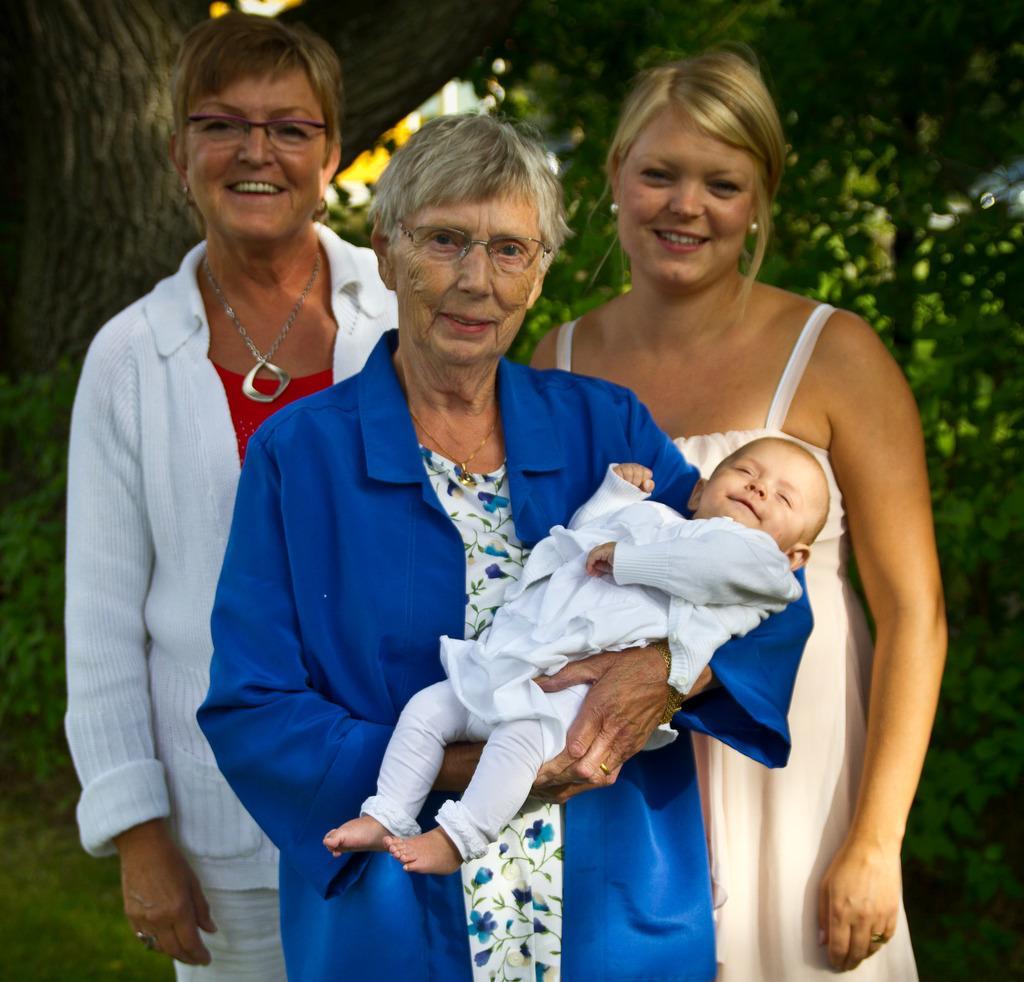In one or two sentences, can you explain what this image depicts? In this image I can see four people with different color dresses. In the background I can see the trees. 